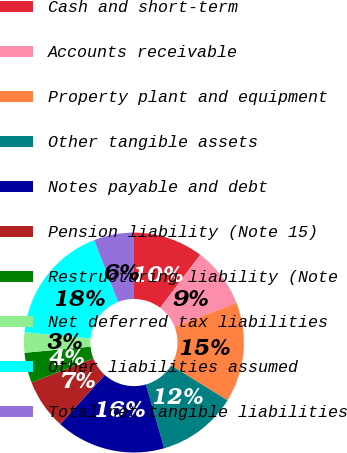<chart> <loc_0><loc_0><loc_500><loc_500><pie_chart><fcel>Cash and short-term<fcel>Accounts receivable<fcel>Property plant and equipment<fcel>Other tangible assets<fcel>Notes payable and debt<fcel>Pension liability (Note 15)<fcel>Restructuring liability (Note<fcel>Net deferred tax liabilities<fcel>Other liabilities assumed<fcel>Total net tangible liabilities<nl><fcel>10.29%<fcel>8.83%<fcel>14.68%<fcel>11.76%<fcel>16.14%<fcel>7.37%<fcel>4.44%<fcel>2.98%<fcel>17.61%<fcel>5.9%<nl></chart> 